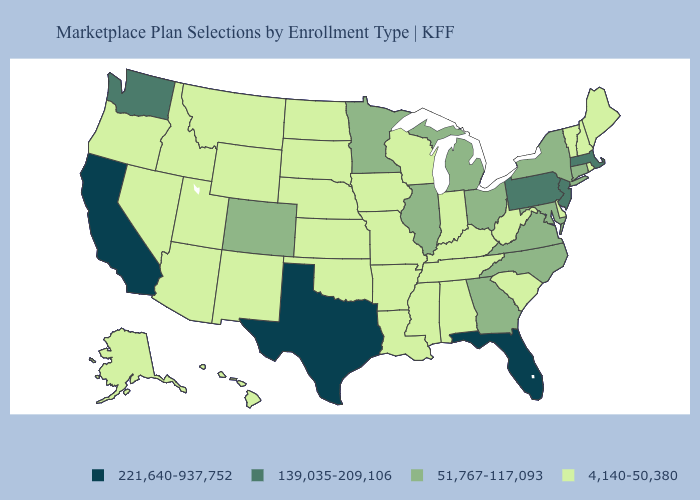Does Colorado have the highest value in the USA?
Keep it brief. No. Among the states that border Texas , which have the lowest value?
Quick response, please. Arkansas, Louisiana, New Mexico, Oklahoma. Which states hav the highest value in the South?
Answer briefly. Florida, Texas. What is the value of New Jersey?
Quick response, please. 139,035-209,106. What is the lowest value in states that border Oklahoma?
Short answer required. 4,140-50,380. Name the states that have a value in the range 221,640-937,752?
Give a very brief answer. California, Florida, Texas. Does Washington have the lowest value in the West?
Be succinct. No. Does the first symbol in the legend represent the smallest category?
Concise answer only. No. What is the value of Connecticut?
Write a very short answer. 51,767-117,093. Name the states that have a value in the range 4,140-50,380?
Short answer required. Alabama, Alaska, Arizona, Arkansas, Delaware, Hawaii, Idaho, Indiana, Iowa, Kansas, Kentucky, Louisiana, Maine, Mississippi, Missouri, Montana, Nebraska, Nevada, New Hampshire, New Mexico, North Dakota, Oklahoma, Oregon, Rhode Island, South Carolina, South Dakota, Tennessee, Utah, Vermont, West Virginia, Wisconsin, Wyoming. Does Nebraska have the lowest value in the USA?
Concise answer only. Yes. Does the first symbol in the legend represent the smallest category?
Be succinct. No. What is the lowest value in states that border Massachusetts?
Keep it brief. 4,140-50,380. 